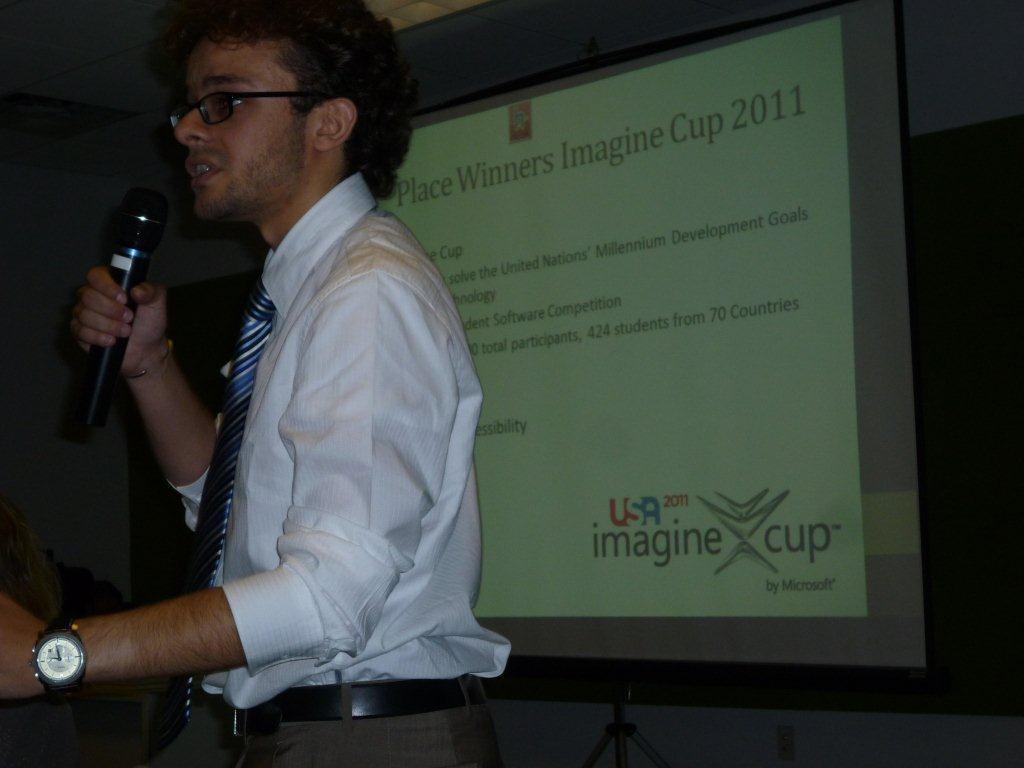Describe this image in one or two sentences. there is a person talking in a microphone 